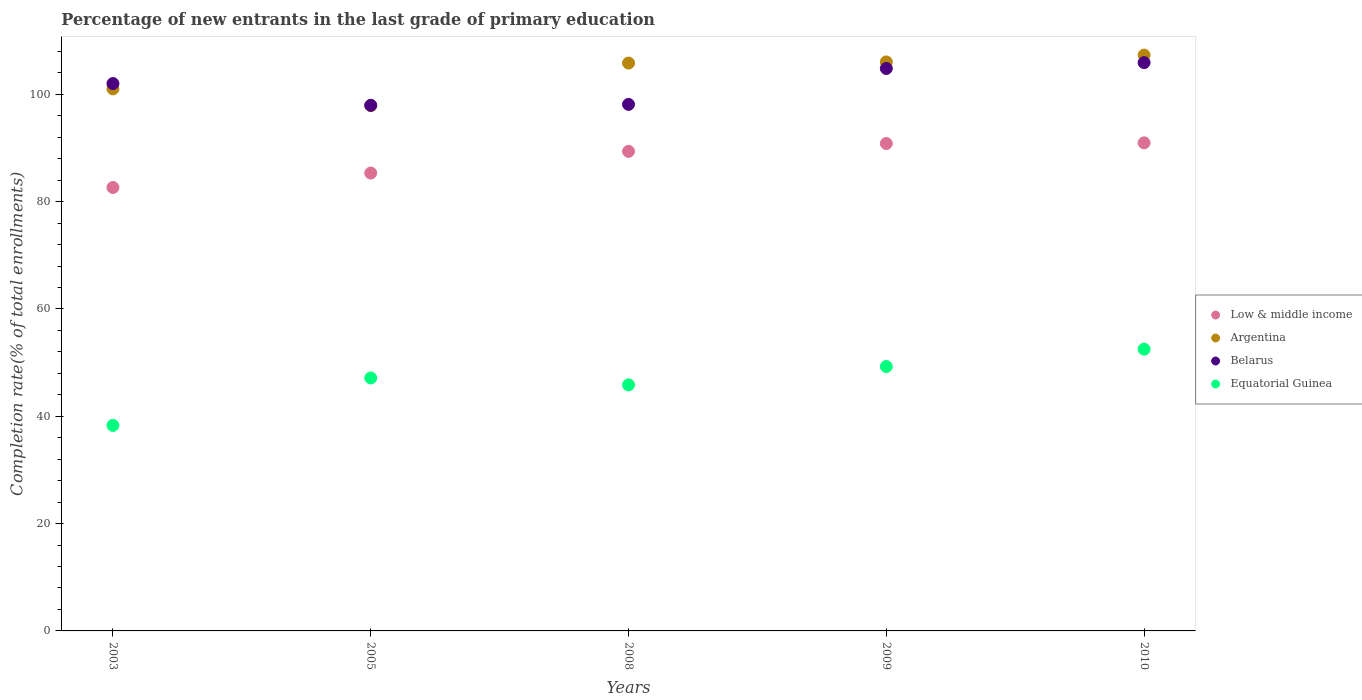How many different coloured dotlines are there?
Keep it short and to the point. 4. Is the number of dotlines equal to the number of legend labels?
Your answer should be compact. Yes. What is the percentage of new entrants in Equatorial Guinea in 2003?
Provide a succinct answer. 38.3. Across all years, what is the maximum percentage of new entrants in Argentina?
Keep it short and to the point. 107.31. Across all years, what is the minimum percentage of new entrants in Argentina?
Keep it short and to the point. 97.89. In which year was the percentage of new entrants in Argentina minimum?
Provide a short and direct response. 2005. What is the total percentage of new entrants in Belarus in the graph?
Your answer should be compact. 508.78. What is the difference between the percentage of new entrants in Equatorial Guinea in 2009 and that in 2010?
Ensure brevity in your answer.  -3.23. What is the difference between the percentage of new entrants in Low & middle income in 2010 and the percentage of new entrants in Equatorial Guinea in 2008?
Your answer should be compact. 45.1. What is the average percentage of new entrants in Low & middle income per year?
Ensure brevity in your answer.  87.82. In the year 2003, what is the difference between the percentage of new entrants in Argentina and percentage of new entrants in Low & middle income?
Provide a short and direct response. 18.37. In how many years, is the percentage of new entrants in Low & middle income greater than 80 %?
Provide a short and direct response. 5. What is the ratio of the percentage of new entrants in Belarus in 2003 to that in 2008?
Make the answer very short. 1.04. What is the difference between the highest and the second highest percentage of new entrants in Argentina?
Offer a terse response. 1.28. What is the difference between the highest and the lowest percentage of new entrants in Belarus?
Your response must be concise. 7.96. Is the sum of the percentage of new entrants in Belarus in 2008 and 2009 greater than the maximum percentage of new entrants in Argentina across all years?
Make the answer very short. Yes. Is it the case that in every year, the sum of the percentage of new entrants in Low & middle income and percentage of new entrants in Equatorial Guinea  is greater than the sum of percentage of new entrants in Argentina and percentage of new entrants in Belarus?
Your response must be concise. No. Is it the case that in every year, the sum of the percentage of new entrants in Equatorial Guinea and percentage of new entrants in Belarus  is greater than the percentage of new entrants in Argentina?
Give a very brief answer. Yes. Does the percentage of new entrants in Argentina monotonically increase over the years?
Make the answer very short. No. Is the percentage of new entrants in Argentina strictly less than the percentage of new entrants in Low & middle income over the years?
Offer a very short reply. No. What is the difference between two consecutive major ticks on the Y-axis?
Your answer should be compact. 20. Are the values on the major ticks of Y-axis written in scientific E-notation?
Offer a terse response. No. How many legend labels are there?
Give a very brief answer. 4. What is the title of the graph?
Give a very brief answer. Percentage of new entrants in the last grade of primary education. Does "Belarus" appear as one of the legend labels in the graph?
Your response must be concise. Yes. What is the label or title of the Y-axis?
Your answer should be compact. Completion rate(% of total enrollments). What is the Completion rate(% of total enrollments) of Low & middle income in 2003?
Provide a succinct answer. 82.63. What is the Completion rate(% of total enrollments) in Argentina in 2003?
Offer a very short reply. 101. What is the Completion rate(% of total enrollments) of Belarus in 2003?
Ensure brevity in your answer.  102. What is the Completion rate(% of total enrollments) in Equatorial Guinea in 2003?
Keep it short and to the point. 38.3. What is the Completion rate(% of total enrollments) of Low & middle income in 2005?
Give a very brief answer. 85.33. What is the Completion rate(% of total enrollments) in Argentina in 2005?
Make the answer very short. 97.89. What is the Completion rate(% of total enrollments) in Belarus in 2005?
Provide a short and direct response. 97.95. What is the Completion rate(% of total enrollments) of Equatorial Guinea in 2005?
Provide a short and direct response. 47.14. What is the Completion rate(% of total enrollments) in Low & middle income in 2008?
Keep it short and to the point. 89.37. What is the Completion rate(% of total enrollments) of Argentina in 2008?
Offer a terse response. 105.82. What is the Completion rate(% of total enrollments) of Belarus in 2008?
Offer a terse response. 98.12. What is the Completion rate(% of total enrollments) of Equatorial Guinea in 2008?
Your answer should be compact. 45.85. What is the Completion rate(% of total enrollments) of Low & middle income in 2009?
Your response must be concise. 90.83. What is the Completion rate(% of total enrollments) of Argentina in 2009?
Your response must be concise. 106.03. What is the Completion rate(% of total enrollments) of Belarus in 2009?
Your answer should be very brief. 104.81. What is the Completion rate(% of total enrollments) in Equatorial Guinea in 2009?
Ensure brevity in your answer.  49.27. What is the Completion rate(% of total enrollments) of Low & middle income in 2010?
Your answer should be compact. 90.95. What is the Completion rate(% of total enrollments) of Argentina in 2010?
Give a very brief answer. 107.31. What is the Completion rate(% of total enrollments) in Belarus in 2010?
Ensure brevity in your answer.  105.9. What is the Completion rate(% of total enrollments) in Equatorial Guinea in 2010?
Ensure brevity in your answer.  52.5. Across all years, what is the maximum Completion rate(% of total enrollments) of Low & middle income?
Give a very brief answer. 90.95. Across all years, what is the maximum Completion rate(% of total enrollments) of Argentina?
Offer a very short reply. 107.31. Across all years, what is the maximum Completion rate(% of total enrollments) of Belarus?
Your answer should be very brief. 105.9. Across all years, what is the maximum Completion rate(% of total enrollments) in Equatorial Guinea?
Keep it short and to the point. 52.5. Across all years, what is the minimum Completion rate(% of total enrollments) of Low & middle income?
Your answer should be very brief. 82.63. Across all years, what is the minimum Completion rate(% of total enrollments) of Argentina?
Your response must be concise. 97.89. Across all years, what is the minimum Completion rate(% of total enrollments) in Belarus?
Provide a succinct answer. 97.95. Across all years, what is the minimum Completion rate(% of total enrollments) in Equatorial Guinea?
Offer a very short reply. 38.3. What is the total Completion rate(% of total enrollments) in Low & middle income in the graph?
Your answer should be compact. 439.11. What is the total Completion rate(% of total enrollments) in Argentina in the graph?
Ensure brevity in your answer.  518.05. What is the total Completion rate(% of total enrollments) in Belarus in the graph?
Your answer should be compact. 508.78. What is the total Completion rate(% of total enrollments) of Equatorial Guinea in the graph?
Your answer should be very brief. 233.07. What is the difference between the Completion rate(% of total enrollments) in Low & middle income in 2003 and that in 2005?
Your answer should be compact. -2.7. What is the difference between the Completion rate(% of total enrollments) of Argentina in 2003 and that in 2005?
Ensure brevity in your answer.  3.12. What is the difference between the Completion rate(% of total enrollments) in Belarus in 2003 and that in 2005?
Ensure brevity in your answer.  4.05. What is the difference between the Completion rate(% of total enrollments) in Equatorial Guinea in 2003 and that in 2005?
Provide a succinct answer. -8.84. What is the difference between the Completion rate(% of total enrollments) of Low & middle income in 2003 and that in 2008?
Your answer should be compact. -6.74. What is the difference between the Completion rate(% of total enrollments) of Argentina in 2003 and that in 2008?
Your answer should be compact. -4.82. What is the difference between the Completion rate(% of total enrollments) in Belarus in 2003 and that in 2008?
Offer a very short reply. 3.88. What is the difference between the Completion rate(% of total enrollments) in Equatorial Guinea in 2003 and that in 2008?
Keep it short and to the point. -7.55. What is the difference between the Completion rate(% of total enrollments) in Low & middle income in 2003 and that in 2009?
Offer a terse response. -8.2. What is the difference between the Completion rate(% of total enrollments) in Argentina in 2003 and that in 2009?
Provide a short and direct response. -5.02. What is the difference between the Completion rate(% of total enrollments) of Belarus in 2003 and that in 2009?
Give a very brief answer. -2.81. What is the difference between the Completion rate(% of total enrollments) in Equatorial Guinea in 2003 and that in 2009?
Offer a very short reply. -10.97. What is the difference between the Completion rate(% of total enrollments) of Low & middle income in 2003 and that in 2010?
Make the answer very short. -8.32. What is the difference between the Completion rate(% of total enrollments) of Argentina in 2003 and that in 2010?
Your answer should be compact. -6.3. What is the difference between the Completion rate(% of total enrollments) of Belarus in 2003 and that in 2010?
Give a very brief answer. -3.91. What is the difference between the Completion rate(% of total enrollments) in Equatorial Guinea in 2003 and that in 2010?
Your response must be concise. -14.2. What is the difference between the Completion rate(% of total enrollments) of Low & middle income in 2005 and that in 2008?
Make the answer very short. -4.04. What is the difference between the Completion rate(% of total enrollments) of Argentina in 2005 and that in 2008?
Your answer should be compact. -7.93. What is the difference between the Completion rate(% of total enrollments) of Belarus in 2005 and that in 2008?
Your response must be concise. -0.17. What is the difference between the Completion rate(% of total enrollments) of Equatorial Guinea in 2005 and that in 2008?
Provide a succinct answer. 1.29. What is the difference between the Completion rate(% of total enrollments) in Low & middle income in 2005 and that in 2009?
Your response must be concise. -5.5. What is the difference between the Completion rate(% of total enrollments) of Argentina in 2005 and that in 2009?
Your response must be concise. -8.14. What is the difference between the Completion rate(% of total enrollments) of Belarus in 2005 and that in 2009?
Give a very brief answer. -6.86. What is the difference between the Completion rate(% of total enrollments) of Equatorial Guinea in 2005 and that in 2009?
Your answer should be very brief. -2.13. What is the difference between the Completion rate(% of total enrollments) of Low & middle income in 2005 and that in 2010?
Your response must be concise. -5.63. What is the difference between the Completion rate(% of total enrollments) in Argentina in 2005 and that in 2010?
Your answer should be compact. -9.42. What is the difference between the Completion rate(% of total enrollments) of Belarus in 2005 and that in 2010?
Provide a succinct answer. -7.96. What is the difference between the Completion rate(% of total enrollments) in Equatorial Guinea in 2005 and that in 2010?
Your answer should be very brief. -5.36. What is the difference between the Completion rate(% of total enrollments) in Low & middle income in 2008 and that in 2009?
Keep it short and to the point. -1.46. What is the difference between the Completion rate(% of total enrollments) of Argentina in 2008 and that in 2009?
Your answer should be very brief. -0.21. What is the difference between the Completion rate(% of total enrollments) of Belarus in 2008 and that in 2009?
Ensure brevity in your answer.  -6.69. What is the difference between the Completion rate(% of total enrollments) in Equatorial Guinea in 2008 and that in 2009?
Provide a succinct answer. -3.42. What is the difference between the Completion rate(% of total enrollments) in Low & middle income in 2008 and that in 2010?
Provide a succinct answer. -1.58. What is the difference between the Completion rate(% of total enrollments) of Argentina in 2008 and that in 2010?
Provide a succinct answer. -1.48. What is the difference between the Completion rate(% of total enrollments) in Belarus in 2008 and that in 2010?
Your response must be concise. -7.79. What is the difference between the Completion rate(% of total enrollments) of Equatorial Guinea in 2008 and that in 2010?
Your answer should be very brief. -6.65. What is the difference between the Completion rate(% of total enrollments) of Low & middle income in 2009 and that in 2010?
Offer a terse response. -0.12. What is the difference between the Completion rate(% of total enrollments) of Argentina in 2009 and that in 2010?
Ensure brevity in your answer.  -1.28. What is the difference between the Completion rate(% of total enrollments) of Belarus in 2009 and that in 2010?
Give a very brief answer. -1.1. What is the difference between the Completion rate(% of total enrollments) of Equatorial Guinea in 2009 and that in 2010?
Your response must be concise. -3.23. What is the difference between the Completion rate(% of total enrollments) in Low & middle income in 2003 and the Completion rate(% of total enrollments) in Argentina in 2005?
Make the answer very short. -15.26. What is the difference between the Completion rate(% of total enrollments) in Low & middle income in 2003 and the Completion rate(% of total enrollments) in Belarus in 2005?
Offer a terse response. -15.32. What is the difference between the Completion rate(% of total enrollments) of Low & middle income in 2003 and the Completion rate(% of total enrollments) of Equatorial Guinea in 2005?
Your answer should be compact. 35.49. What is the difference between the Completion rate(% of total enrollments) in Argentina in 2003 and the Completion rate(% of total enrollments) in Belarus in 2005?
Offer a terse response. 3.06. What is the difference between the Completion rate(% of total enrollments) in Argentina in 2003 and the Completion rate(% of total enrollments) in Equatorial Guinea in 2005?
Provide a succinct answer. 53.86. What is the difference between the Completion rate(% of total enrollments) of Belarus in 2003 and the Completion rate(% of total enrollments) of Equatorial Guinea in 2005?
Make the answer very short. 54.86. What is the difference between the Completion rate(% of total enrollments) in Low & middle income in 2003 and the Completion rate(% of total enrollments) in Argentina in 2008?
Keep it short and to the point. -23.19. What is the difference between the Completion rate(% of total enrollments) in Low & middle income in 2003 and the Completion rate(% of total enrollments) in Belarus in 2008?
Your response must be concise. -15.49. What is the difference between the Completion rate(% of total enrollments) in Low & middle income in 2003 and the Completion rate(% of total enrollments) in Equatorial Guinea in 2008?
Ensure brevity in your answer.  36.78. What is the difference between the Completion rate(% of total enrollments) in Argentina in 2003 and the Completion rate(% of total enrollments) in Belarus in 2008?
Your answer should be compact. 2.89. What is the difference between the Completion rate(% of total enrollments) in Argentina in 2003 and the Completion rate(% of total enrollments) in Equatorial Guinea in 2008?
Keep it short and to the point. 55.15. What is the difference between the Completion rate(% of total enrollments) in Belarus in 2003 and the Completion rate(% of total enrollments) in Equatorial Guinea in 2008?
Keep it short and to the point. 56.15. What is the difference between the Completion rate(% of total enrollments) of Low & middle income in 2003 and the Completion rate(% of total enrollments) of Argentina in 2009?
Provide a succinct answer. -23.4. What is the difference between the Completion rate(% of total enrollments) of Low & middle income in 2003 and the Completion rate(% of total enrollments) of Belarus in 2009?
Your answer should be very brief. -22.18. What is the difference between the Completion rate(% of total enrollments) in Low & middle income in 2003 and the Completion rate(% of total enrollments) in Equatorial Guinea in 2009?
Ensure brevity in your answer.  33.36. What is the difference between the Completion rate(% of total enrollments) in Argentina in 2003 and the Completion rate(% of total enrollments) in Belarus in 2009?
Your response must be concise. -3.81. What is the difference between the Completion rate(% of total enrollments) in Argentina in 2003 and the Completion rate(% of total enrollments) in Equatorial Guinea in 2009?
Offer a very short reply. 51.73. What is the difference between the Completion rate(% of total enrollments) in Belarus in 2003 and the Completion rate(% of total enrollments) in Equatorial Guinea in 2009?
Offer a terse response. 52.73. What is the difference between the Completion rate(% of total enrollments) in Low & middle income in 2003 and the Completion rate(% of total enrollments) in Argentina in 2010?
Your response must be concise. -24.67. What is the difference between the Completion rate(% of total enrollments) of Low & middle income in 2003 and the Completion rate(% of total enrollments) of Belarus in 2010?
Provide a succinct answer. -23.27. What is the difference between the Completion rate(% of total enrollments) of Low & middle income in 2003 and the Completion rate(% of total enrollments) of Equatorial Guinea in 2010?
Give a very brief answer. 30.13. What is the difference between the Completion rate(% of total enrollments) in Argentina in 2003 and the Completion rate(% of total enrollments) in Belarus in 2010?
Offer a very short reply. -4.9. What is the difference between the Completion rate(% of total enrollments) of Argentina in 2003 and the Completion rate(% of total enrollments) of Equatorial Guinea in 2010?
Provide a succinct answer. 48.5. What is the difference between the Completion rate(% of total enrollments) of Belarus in 2003 and the Completion rate(% of total enrollments) of Equatorial Guinea in 2010?
Your answer should be very brief. 49.49. What is the difference between the Completion rate(% of total enrollments) in Low & middle income in 2005 and the Completion rate(% of total enrollments) in Argentina in 2008?
Make the answer very short. -20.5. What is the difference between the Completion rate(% of total enrollments) in Low & middle income in 2005 and the Completion rate(% of total enrollments) in Belarus in 2008?
Offer a very short reply. -12.79. What is the difference between the Completion rate(% of total enrollments) of Low & middle income in 2005 and the Completion rate(% of total enrollments) of Equatorial Guinea in 2008?
Keep it short and to the point. 39.47. What is the difference between the Completion rate(% of total enrollments) in Argentina in 2005 and the Completion rate(% of total enrollments) in Belarus in 2008?
Make the answer very short. -0.23. What is the difference between the Completion rate(% of total enrollments) of Argentina in 2005 and the Completion rate(% of total enrollments) of Equatorial Guinea in 2008?
Your answer should be compact. 52.04. What is the difference between the Completion rate(% of total enrollments) in Belarus in 2005 and the Completion rate(% of total enrollments) in Equatorial Guinea in 2008?
Your response must be concise. 52.1. What is the difference between the Completion rate(% of total enrollments) of Low & middle income in 2005 and the Completion rate(% of total enrollments) of Argentina in 2009?
Offer a very short reply. -20.7. What is the difference between the Completion rate(% of total enrollments) of Low & middle income in 2005 and the Completion rate(% of total enrollments) of Belarus in 2009?
Offer a very short reply. -19.48. What is the difference between the Completion rate(% of total enrollments) of Low & middle income in 2005 and the Completion rate(% of total enrollments) of Equatorial Guinea in 2009?
Provide a succinct answer. 36.05. What is the difference between the Completion rate(% of total enrollments) of Argentina in 2005 and the Completion rate(% of total enrollments) of Belarus in 2009?
Your answer should be compact. -6.92. What is the difference between the Completion rate(% of total enrollments) in Argentina in 2005 and the Completion rate(% of total enrollments) in Equatorial Guinea in 2009?
Give a very brief answer. 48.62. What is the difference between the Completion rate(% of total enrollments) of Belarus in 2005 and the Completion rate(% of total enrollments) of Equatorial Guinea in 2009?
Make the answer very short. 48.68. What is the difference between the Completion rate(% of total enrollments) in Low & middle income in 2005 and the Completion rate(% of total enrollments) in Argentina in 2010?
Your response must be concise. -21.98. What is the difference between the Completion rate(% of total enrollments) in Low & middle income in 2005 and the Completion rate(% of total enrollments) in Belarus in 2010?
Offer a very short reply. -20.58. What is the difference between the Completion rate(% of total enrollments) of Low & middle income in 2005 and the Completion rate(% of total enrollments) of Equatorial Guinea in 2010?
Provide a succinct answer. 32.82. What is the difference between the Completion rate(% of total enrollments) of Argentina in 2005 and the Completion rate(% of total enrollments) of Belarus in 2010?
Your answer should be compact. -8.02. What is the difference between the Completion rate(% of total enrollments) in Argentina in 2005 and the Completion rate(% of total enrollments) in Equatorial Guinea in 2010?
Keep it short and to the point. 45.38. What is the difference between the Completion rate(% of total enrollments) in Belarus in 2005 and the Completion rate(% of total enrollments) in Equatorial Guinea in 2010?
Provide a short and direct response. 45.44. What is the difference between the Completion rate(% of total enrollments) of Low & middle income in 2008 and the Completion rate(% of total enrollments) of Argentina in 2009?
Offer a terse response. -16.66. What is the difference between the Completion rate(% of total enrollments) of Low & middle income in 2008 and the Completion rate(% of total enrollments) of Belarus in 2009?
Offer a very short reply. -15.44. What is the difference between the Completion rate(% of total enrollments) of Low & middle income in 2008 and the Completion rate(% of total enrollments) of Equatorial Guinea in 2009?
Offer a terse response. 40.1. What is the difference between the Completion rate(% of total enrollments) of Argentina in 2008 and the Completion rate(% of total enrollments) of Belarus in 2009?
Provide a short and direct response. 1.01. What is the difference between the Completion rate(% of total enrollments) in Argentina in 2008 and the Completion rate(% of total enrollments) in Equatorial Guinea in 2009?
Ensure brevity in your answer.  56.55. What is the difference between the Completion rate(% of total enrollments) of Belarus in 2008 and the Completion rate(% of total enrollments) of Equatorial Guinea in 2009?
Your answer should be compact. 48.85. What is the difference between the Completion rate(% of total enrollments) in Low & middle income in 2008 and the Completion rate(% of total enrollments) in Argentina in 2010?
Offer a terse response. -17.94. What is the difference between the Completion rate(% of total enrollments) in Low & middle income in 2008 and the Completion rate(% of total enrollments) in Belarus in 2010?
Keep it short and to the point. -16.54. What is the difference between the Completion rate(% of total enrollments) in Low & middle income in 2008 and the Completion rate(% of total enrollments) in Equatorial Guinea in 2010?
Provide a succinct answer. 36.86. What is the difference between the Completion rate(% of total enrollments) in Argentina in 2008 and the Completion rate(% of total enrollments) in Belarus in 2010?
Make the answer very short. -0.08. What is the difference between the Completion rate(% of total enrollments) of Argentina in 2008 and the Completion rate(% of total enrollments) of Equatorial Guinea in 2010?
Your answer should be very brief. 53.32. What is the difference between the Completion rate(% of total enrollments) of Belarus in 2008 and the Completion rate(% of total enrollments) of Equatorial Guinea in 2010?
Make the answer very short. 45.61. What is the difference between the Completion rate(% of total enrollments) in Low & middle income in 2009 and the Completion rate(% of total enrollments) in Argentina in 2010?
Provide a succinct answer. -16.48. What is the difference between the Completion rate(% of total enrollments) of Low & middle income in 2009 and the Completion rate(% of total enrollments) of Belarus in 2010?
Ensure brevity in your answer.  -15.07. What is the difference between the Completion rate(% of total enrollments) in Low & middle income in 2009 and the Completion rate(% of total enrollments) in Equatorial Guinea in 2010?
Ensure brevity in your answer.  38.33. What is the difference between the Completion rate(% of total enrollments) in Argentina in 2009 and the Completion rate(% of total enrollments) in Belarus in 2010?
Provide a succinct answer. 0.12. What is the difference between the Completion rate(% of total enrollments) of Argentina in 2009 and the Completion rate(% of total enrollments) of Equatorial Guinea in 2010?
Keep it short and to the point. 53.52. What is the difference between the Completion rate(% of total enrollments) of Belarus in 2009 and the Completion rate(% of total enrollments) of Equatorial Guinea in 2010?
Offer a terse response. 52.31. What is the average Completion rate(% of total enrollments) in Low & middle income per year?
Your response must be concise. 87.82. What is the average Completion rate(% of total enrollments) of Argentina per year?
Ensure brevity in your answer.  103.61. What is the average Completion rate(% of total enrollments) in Belarus per year?
Your answer should be very brief. 101.76. What is the average Completion rate(% of total enrollments) of Equatorial Guinea per year?
Give a very brief answer. 46.61. In the year 2003, what is the difference between the Completion rate(% of total enrollments) of Low & middle income and Completion rate(% of total enrollments) of Argentina?
Offer a terse response. -18.37. In the year 2003, what is the difference between the Completion rate(% of total enrollments) of Low & middle income and Completion rate(% of total enrollments) of Belarus?
Your answer should be compact. -19.37. In the year 2003, what is the difference between the Completion rate(% of total enrollments) in Low & middle income and Completion rate(% of total enrollments) in Equatorial Guinea?
Your response must be concise. 44.33. In the year 2003, what is the difference between the Completion rate(% of total enrollments) in Argentina and Completion rate(% of total enrollments) in Belarus?
Provide a short and direct response. -0.99. In the year 2003, what is the difference between the Completion rate(% of total enrollments) in Argentina and Completion rate(% of total enrollments) in Equatorial Guinea?
Give a very brief answer. 62.7. In the year 2003, what is the difference between the Completion rate(% of total enrollments) of Belarus and Completion rate(% of total enrollments) of Equatorial Guinea?
Offer a very short reply. 63.7. In the year 2005, what is the difference between the Completion rate(% of total enrollments) of Low & middle income and Completion rate(% of total enrollments) of Argentina?
Offer a very short reply. -12.56. In the year 2005, what is the difference between the Completion rate(% of total enrollments) in Low & middle income and Completion rate(% of total enrollments) in Belarus?
Provide a short and direct response. -12.62. In the year 2005, what is the difference between the Completion rate(% of total enrollments) in Low & middle income and Completion rate(% of total enrollments) in Equatorial Guinea?
Your response must be concise. 38.18. In the year 2005, what is the difference between the Completion rate(% of total enrollments) in Argentina and Completion rate(% of total enrollments) in Belarus?
Make the answer very short. -0.06. In the year 2005, what is the difference between the Completion rate(% of total enrollments) of Argentina and Completion rate(% of total enrollments) of Equatorial Guinea?
Provide a succinct answer. 50.75. In the year 2005, what is the difference between the Completion rate(% of total enrollments) of Belarus and Completion rate(% of total enrollments) of Equatorial Guinea?
Your answer should be very brief. 50.81. In the year 2008, what is the difference between the Completion rate(% of total enrollments) of Low & middle income and Completion rate(% of total enrollments) of Argentina?
Keep it short and to the point. -16.45. In the year 2008, what is the difference between the Completion rate(% of total enrollments) in Low & middle income and Completion rate(% of total enrollments) in Belarus?
Make the answer very short. -8.75. In the year 2008, what is the difference between the Completion rate(% of total enrollments) in Low & middle income and Completion rate(% of total enrollments) in Equatorial Guinea?
Make the answer very short. 43.52. In the year 2008, what is the difference between the Completion rate(% of total enrollments) in Argentina and Completion rate(% of total enrollments) in Belarus?
Keep it short and to the point. 7.7. In the year 2008, what is the difference between the Completion rate(% of total enrollments) in Argentina and Completion rate(% of total enrollments) in Equatorial Guinea?
Offer a very short reply. 59.97. In the year 2008, what is the difference between the Completion rate(% of total enrollments) in Belarus and Completion rate(% of total enrollments) in Equatorial Guinea?
Make the answer very short. 52.27. In the year 2009, what is the difference between the Completion rate(% of total enrollments) in Low & middle income and Completion rate(% of total enrollments) in Argentina?
Your answer should be compact. -15.2. In the year 2009, what is the difference between the Completion rate(% of total enrollments) in Low & middle income and Completion rate(% of total enrollments) in Belarus?
Your answer should be compact. -13.98. In the year 2009, what is the difference between the Completion rate(% of total enrollments) of Low & middle income and Completion rate(% of total enrollments) of Equatorial Guinea?
Provide a succinct answer. 41.56. In the year 2009, what is the difference between the Completion rate(% of total enrollments) in Argentina and Completion rate(% of total enrollments) in Belarus?
Provide a short and direct response. 1.22. In the year 2009, what is the difference between the Completion rate(% of total enrollments) in Argentina and Completion rate(% of total enrollments) in Equatorial Guinea?
Provide a short and direct response. 56.76. In the year 2009, what is the difference between the Completion rate(% of total enrollments) in Belarus and Completion rate(% of total enrollments) in Equatorial Guinea?
Your answer should be compact. 55.54. In the year 2010, what is the difference between the Completion rate(% of total enrollments) in Low & middle income and Completion rate(% of total enrollments) in Argentina?
Provide a succinct answer. -16.35. In the year 2010, what is the difference between the Completion rate(% of total enrollments) of Low & middle income and Completion rate(% of total enrollments) of Belarus?
Your answer should be compact. -14.95. In the year 2010, what is the difference between the Completion rate(% of total enrollments) of Low & middle income and Completion rate(% of total enrollments) of Equatorial Guinea?
Offer a very short reply. 38.45. In the year 2010, what is the difference between the Completion rate(% of total enrollments) of Argentina and Completion rate(% of total enrollments) of Belarus?
Ensure brevity in your answer.  1.4. In the year 2010, what is the difference between the Completion rate(% of total enrollments) of Argentina and Completion rate(% of total enrollments) of Equatorial Guinea?
Provide a succinct answer. 54.8. In the year 2010, what is the difference between the Completion rate(% of total enrollments) in Belarus and Completion rate(% of total enrollments) in Equatorial Guinea?
Ensure brevity in your answer.  53.4. What is the ratio of the Completion rate(% of total enrollments) in Low & middle income in 2003 to that in 2005?
Provide a succinct answer. 0.97. What is the ratio of the Completion rate(% of total enrollments) of Argentina in 2003 to that in 2005?
Give a very brief answer. 1.03. What is the ratio of the Completion rate(% of total enrollments) in Belarus in 2003 to that in 2005?
Offer a terse response. 1.04. What is the ratio of the Completion rate(% of total enrollments) in Equatorial Guinea in 2003 to that in 2005?
Your answer should be very brief. 0.81. What is the ratio of the Completion rate(% of total enrollments) in Low & middle income in 2003 to that in 2008?
Ensure brevity in your answer.  0.92. What is the ratio of the Completion rate(% of total enrollments) of Argentina in 2003 to that in 2008?
Offer a terse response. 0.95. What is the ratio of the Completion rate(% of total enrollments) of Belarus in 2003 to that in 2008?
Keep it short and to the point. 1.04. What is the ratio of the Completion rate(% of total enrollments) in Equatorial Guinea in 2003 to that in 2008?
Make the answer very short. 0.84. What is the ratio of the Completion rate(% of total enrollments) of Low & middle income in 2003 to that in 2009?
Make the answer very short. 0.91. What is the ratio of the Completion rate(% of total enrollments) in Argentina in 2003 to that in 2009?
Provide a short and direct response. 0.95. What is the ratio of the Completion rate(% of total enrollments) of Belarus in 2003 to that in 2009?
Offer a terse response. 0.97. What is the ratio of the Completion rate(% of total enrollments) in Equatorial Guinea in 2003 to that in 2009?
Keep it short and to the point. 0.78. What is the ratio of the Completion rate(% of total enrollments) in Low & middle income in 2003 to that in 2010?
Provide a short and direct response. 0.91. What is the ratio of the Completion rate(% of total enrollments) of Argentina in 2003 to that in 2010?
Give a very brief answer. 0.94. What is the ratio of the Completion rate(% of total enrollments) of Belarus in 2003 to that in 2010?
Offer a very short reply. 0.96. What is the ratio of the Completion rate(% of total enrollments) in Equatorial Guinea in 2003 to that in 2010?
Ensure brevity in your answer.  0.73. What is the ratio of the Completion rate(% of total enrollments) in Low & middle income in 2005 to that in 2008?
Your response must be concise. 0.95. What is the ratio of the Completion rate(% of total enrollments) in Argentina in 2005 to that in 2008?
Offer a terse response. 0.93. What is the ratio of the Completion rate(% of total enrollments) in Equatorial Guinea in 2005 to that in 2008?
Keep it short and to the point. 1.03. What is the ratio of the Completion rate(% of total enrollments) in Low & middle income in 2005 to that in 2009?
Offer a terse response. 0.94. What is the ratio of the Completion rate(% of total enrollments) in Argentina in 2005 to that in 2009?
Give a very brief answer. 0.92. What is the ratio of the Completion rate(% of total enrollments) in Belarus in 2005 to that in 2009?
Offer a terse response. 0.93. What is the ratio of the Completion rate(% of total enrollments) in Equatorial Guinea in 2005 to that in 2009?
Offer a terse response. 0.96. What is the ratio of the Completion rate(% of total enrollments) of Low & middle income in 2005 to that in 2010?
Ensure brevity in your answer.  0.94. What is the ratio of the Completion rate(% of total enrollments) in Argentina in 2005 to that in 2010?
Ensure brevity in your answer.  0.91. What is the ratio of the Completion rate(% of total enrollments) of Belarus in 2005 to that in 2010?
Keep it short and to the point. 0.92. What is the ratio of the Completion rate(% of total enrollments) in Equatorial Guinea in 2005 to that in 2010?
Provide a succinct answer. 0.9. What is the ratio of the Completion rate(% of total enrollments) of Low & middle income in 2008 to that in 2009?
Your answer should be compact. 0.98. What is the ratio of the Completion rate(% of total enrollments) of Belarus in 2008 to that in 2009?
Your answer should be very brief. 0.94. What is the ratio of the Completion rate(% of total enrollments) in Equatorial Guinea in 2008 to that in 2009?
Give a very brief answer. 0.93. What is the ratio of the Completion rate(% of total enrollments) of Low & middle income in 2008 to that in 2010?
Ensure brevity in your answer.  0.98. What is the ratio of the Completion rate(% of total enrollments) in Argentina in 2008 to that in 2010?
Offer a very short reply. 0.99. What is the ratio of the Completion rate(% of total enrollments) of Belarus in 2008 to that in 2010?
Provide a short and direct response. 0.93. What is the ratio of the Completion rate(% of total enrollments) in Equatorial Guinea in 2008 to that in 2010?
Your answer should be compact. 0.87. What is the ratio of the Completion rate(% of total enrollments) in Argentina in 2009 to that in 2010?
Your answer should be very brief. 0.99. What is the ratio of the Completion rate(% of total enrollments) in Belarus in 2009 to that in 2010?
Your answer should be very brief. 0.99. What is the ratio of the Completion rate(% of total enrollments) of Equatorial Guinea in 2009 to that in 2010?
Your response must be concise. 0.94. What is the difference between the highest and the second highest Completion rate(% of total enrollments) in Low & middle income?
Your response must be concise. 0.12. What is the difference between the highest and the second highest Completion rate(% of total enrollments) of Argentina?
Offer a terse response. 1.28. What is the difference between the highest and the second highest Completion rate(% of total enrollments) of Belarus?
Keep it short and to the point. 1.1. What is the difference between the highest and the second highest Completion rate(% of total enrollments) of Equatorial Guinea?
Provide a succinct answer. 3.23. What is the difference between the highest and the lowest Completion rate(% of total enrollments) of Low & middle income?
Provide a short and direct response. 8.32. What is the difference between the highest and the lowest Completion rate(% of total enrollments) of Argentina?
Ensure brevity in your answer.  9.42. What is the difference between the highest and the lowest Completion rate(% of total enrollments) in Belarus?
Keep it short and to the point. 7.96. What is the difference between the highest and the lowest Completion rate(% of total enrollments) in Equatorial Guinea?
Your answer should be very brief. 14.2. 